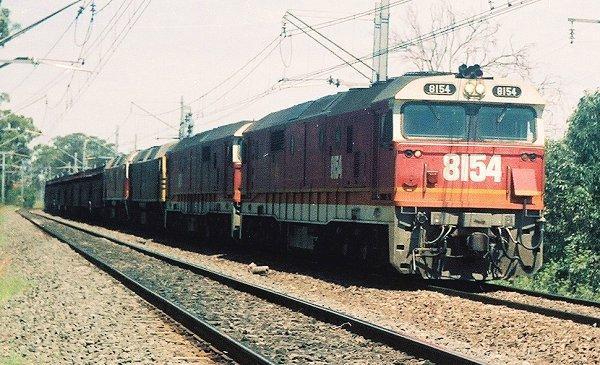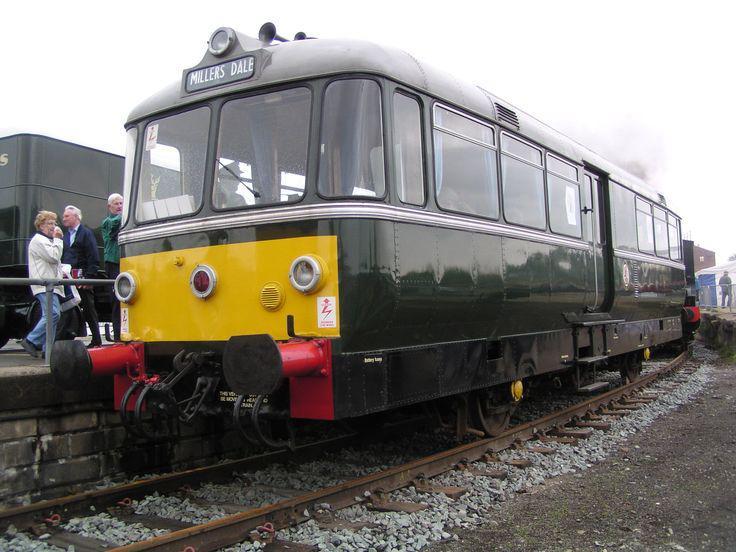The first image is the image on the left, the second image is the image on the right. Evaluate the accuracy of this statement regarding the images: "A train locomotive in each image is a distinct style and color, and positioned at a different angle than that of the other image.". Is it true? Answer yes or no. Yes. The first image is the image on the left, the second image is the image on the right. Evaluate the accuracy of this statement regarding the images: "People are standing by a railing next to a train in one image.". Is it true? Answer yes or no. Yes. 